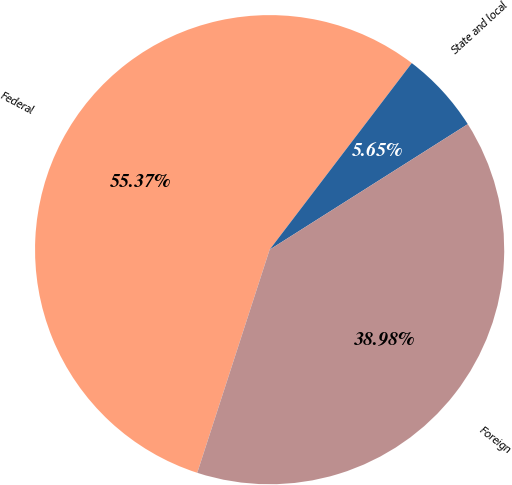Convert chart. <chart><loc_0><loc_0><loc_500><loc_500><pie_chart><fcel>Federal<fcel>State and local<fcel>Foreign<nl><fcel>55.37%<fcel>5.65%<fcel>38.98%<nl></chart> 